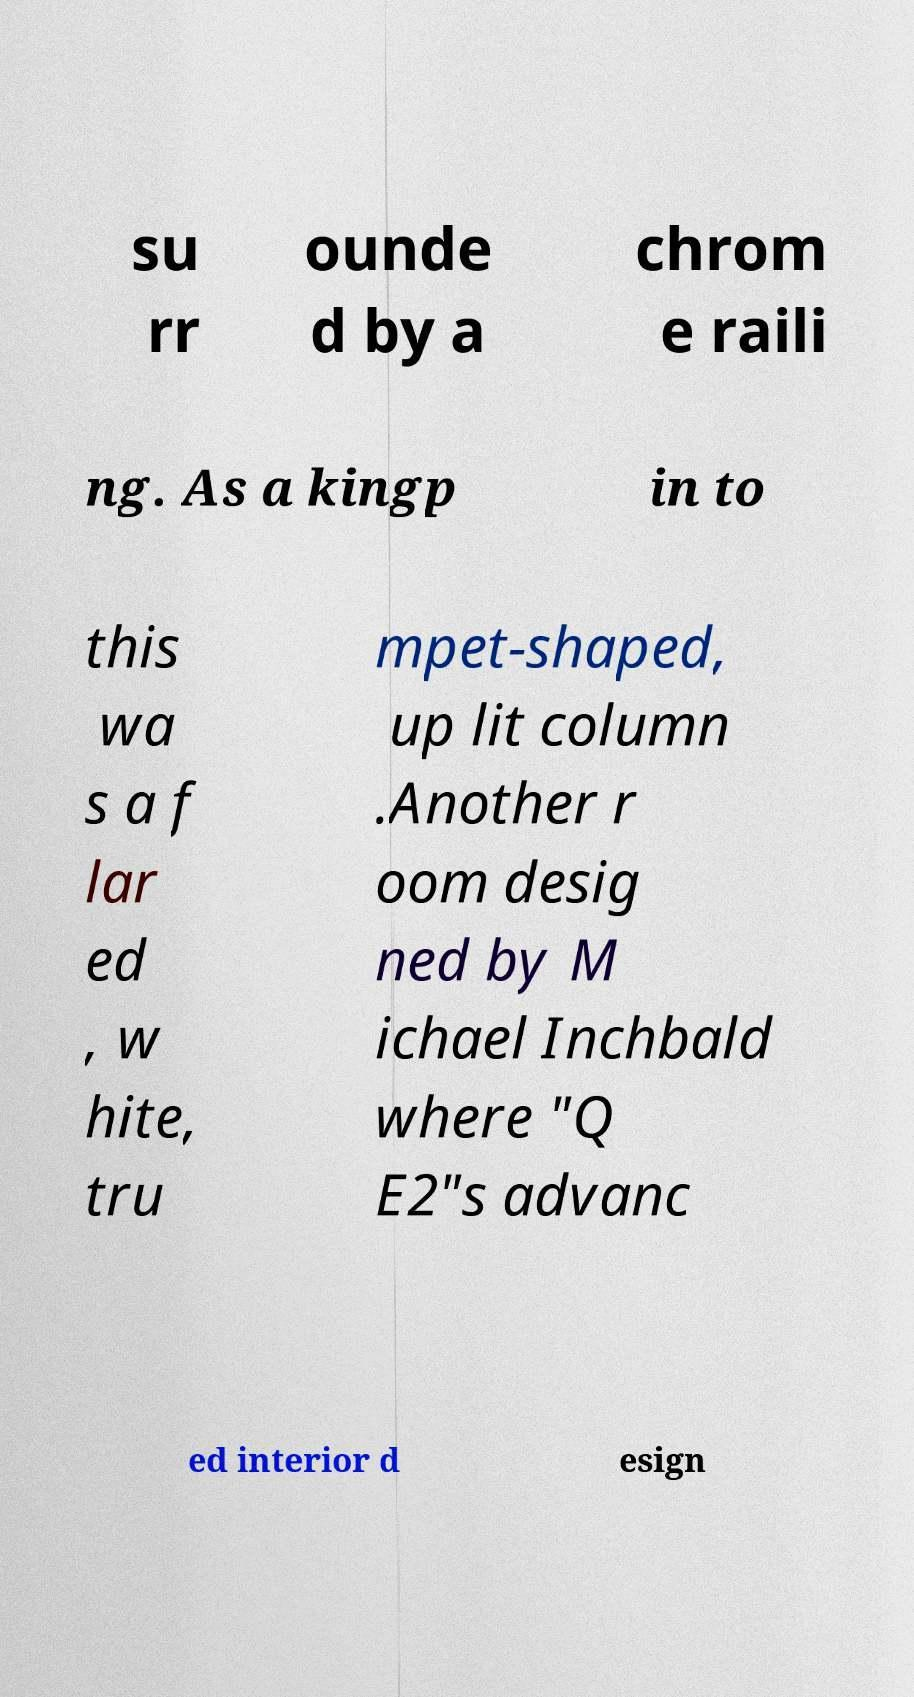What messages or text are displayed in this image? I need them in a readable, typed format. su rr ounde d by a chrom e raili ng. As a kingp in to this wa s a f lar ed , w hite, tru mpet-shaped, up lit column .Another r oom desig ned by M ichael Inchbald where "Q E2"s advanc ed interior d esign 